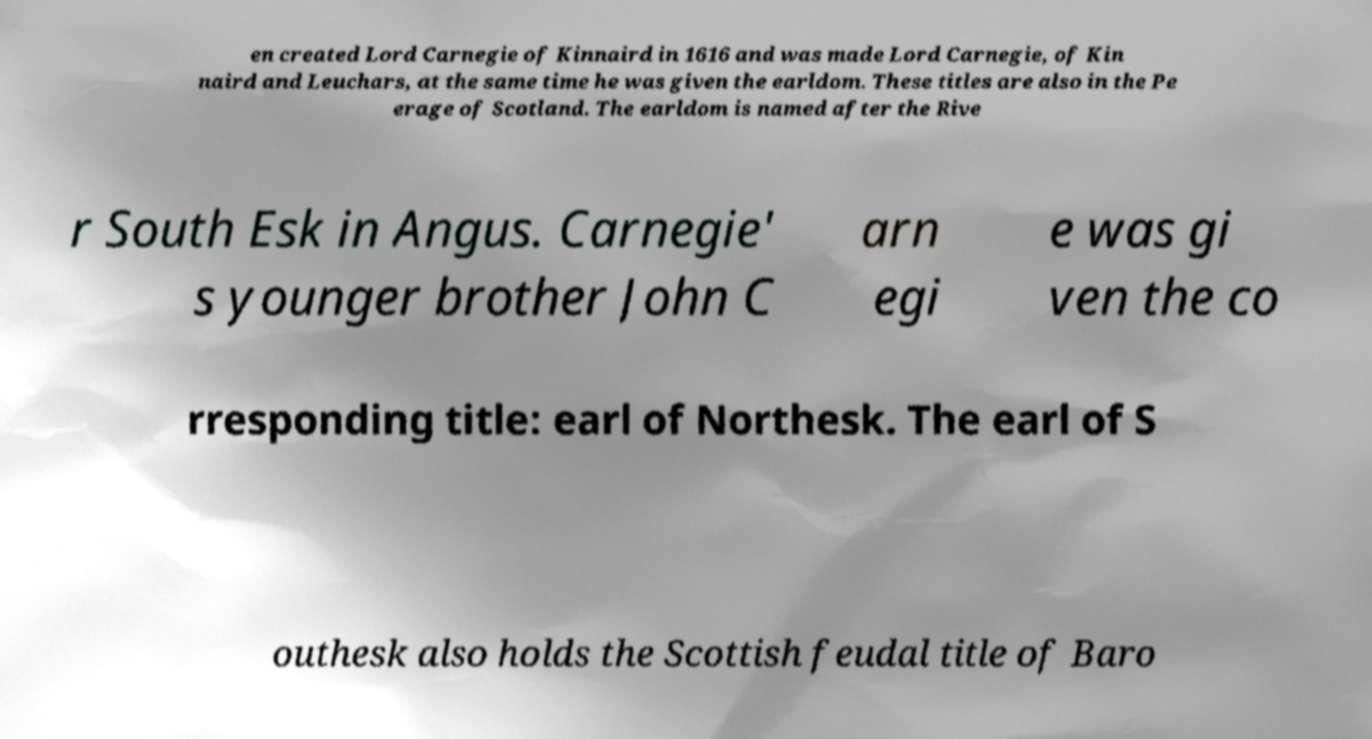I need the written content from this picture converted into text. Can you do that? en created Lord Carnegie of Kinnaird in 1616 and was made Lord Carnegie, of Kin naird and Leuchars, at the same time he was given the earldom. These titles are also in the Pe erage of Scotland. The earldom is named after the Rive r South Esk in Angus. Carnegie' s younger brother John C arn egi e was gi ven the co rresponding title: earl of Northesk. The earl of S outhesk also holds the Scottish feudal title of Baro 